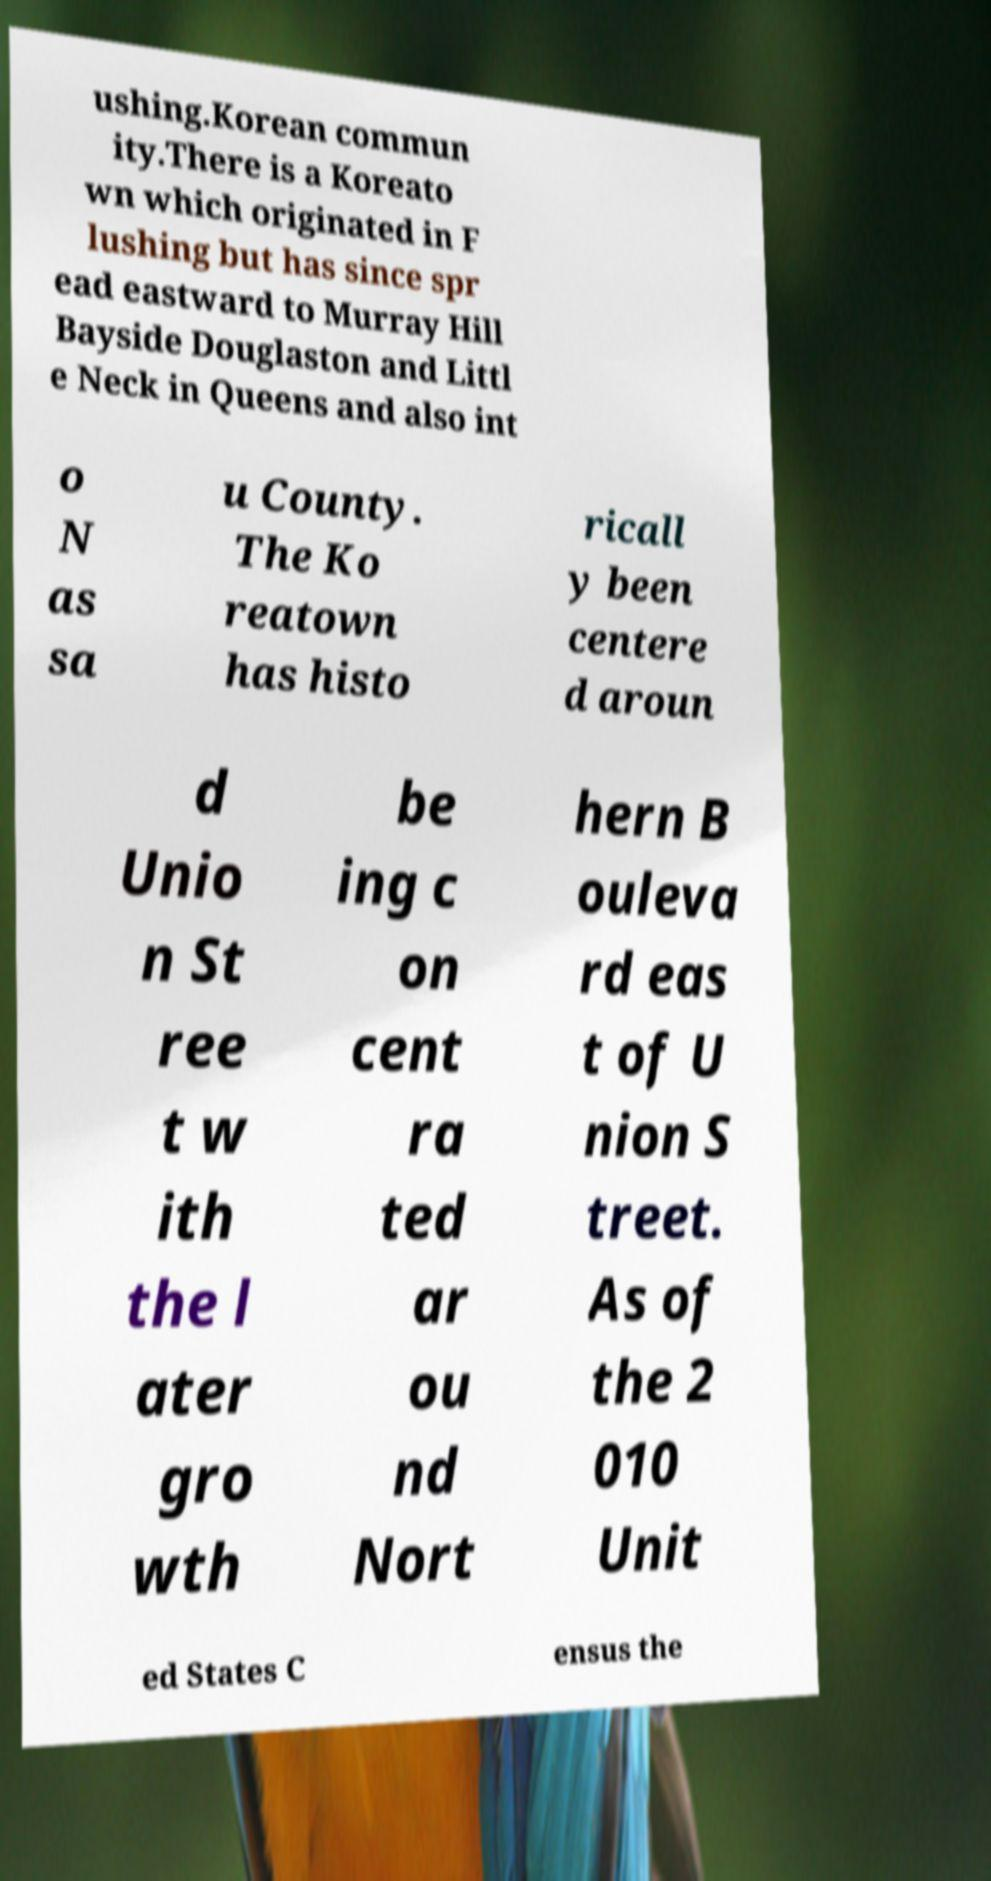Can you read and provide the text displayed in the image?This photo seems to have some interesting text. Can you extract and type it out for me? ushing.Korean commun ity.There is a Koreato wn which originated in F lushing but has since spr ead eastward to Murray Hill Bayside Douglaston and Littl e Neck in Queens and also int o N as sa u County. The Ko reatown has histo ricall y been centere d aroun d Unio n St ree t w ith the l ater gro wth be ing c on cent ra ted ar ou nd Nort hern B ouleva rd eas t of U nion S treet. As of the 2 010 Unit ed States C ensus the 